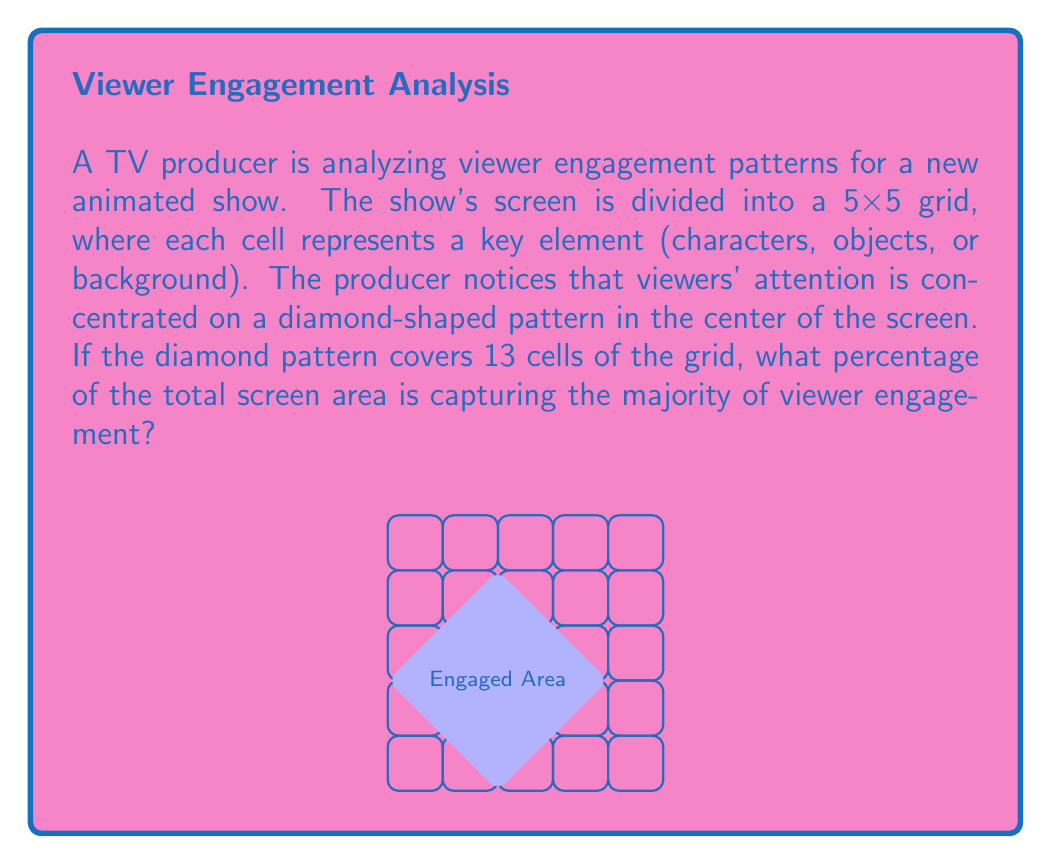What is the answer to this math problem? Let's approach this step-by-step:

1) First, we need to calculate the total number of cells in the grid:
   $$\text{Total cells} = 5 \times 5 = 25$$

2) We're given that the diamond-shaped pattern covers 13 cells.

3) To calculate the percentage, we use the formula:
   $$\text{Percentage} = \frac{\text{Part}}{\text{Whole}} \times 100\%$$

4) Substituting our values:
   $$\text{Percentage} = \frac{13}{25} \times 100\%$$

5) Simplifying:
   $$\text{Percentage} = 0.52 \times 100\% = 52\%$$

Therefore, 52% of the total screen area is capturing the majority of viewer engagement.
Answer: 52% 